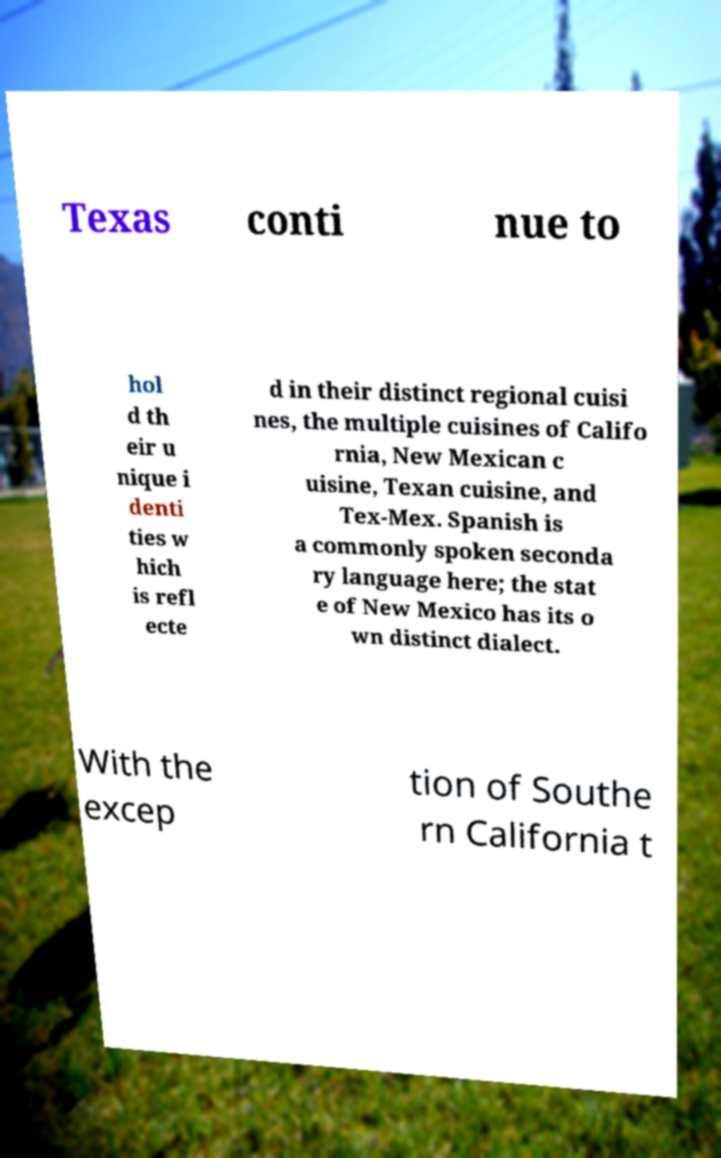Could you extract and type out the text from this image? Texas conti nue to hol d th eir u nique i denti ties w hich is refl ecte d in their distinct regional cuisi nes, the multiple cuisines of Califo rnia, New Mexican c uisine, Texan cuisine, and Tex-Mex. Spanish is a commonly spoken seconda ry language here; the stat e of New Mexico has its o wn distinct dialect. With the excep tion of Southe rn California t 